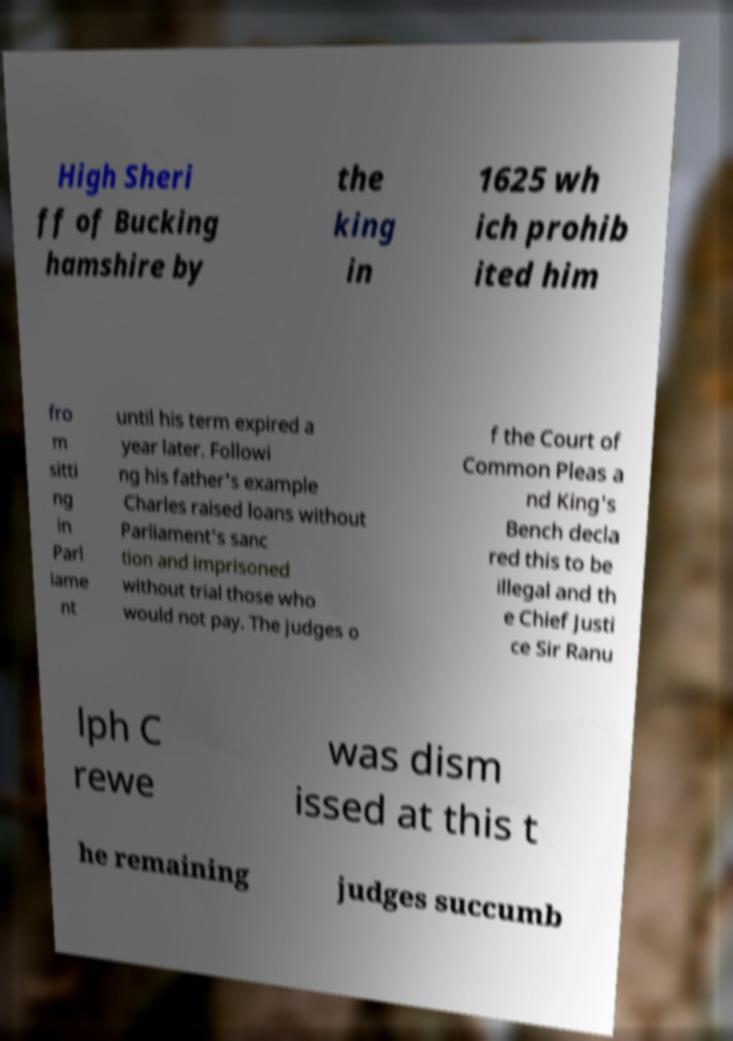Can you read and provide the text displayed in the image?This photo seems to have some interesting text. Can you extract and type it out for me? High Sheri ff of Bucking hamshire by the king in 1625 wh ich prohib ited him fro m sitti ng in Parl iame nt until his term expired a year later. Followi ng his father's example Charles raised loans without Parliament's sanc tion and imprisoned without trial those who would not pay. The judges o f the Court of Common Pleas a nd King's Bench decla red this to be illegal and th e Chief Justi ce Sir Ranu lph C rewe was dism issed at this t he remaining judges succumb 